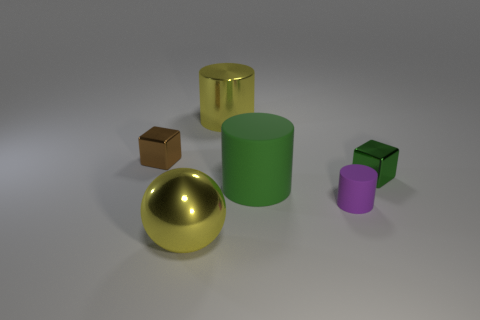Subtract all large cylinders. How many cylinders are left? 1 Add 2 tiny purple metallic blocks. How many objects exist? 8 Subtract all brown blocks. How many blocks are left? 1 Subtract all balls. How many objects are left? 5 Subtract 2 cubes. How many cubes are left? 0 Subtract all blue spheres. Subtract all green cubes. How many spheres are left? 1 Subtract all purple things. Subtract all brown objects. How many objects are left? 4 Add 1 metallic spheres. How many metallic spheres are left? 2 Add 5 green matte cylinders. How many green matte cylinders exist? 6 Subtract 0 purple spheres. How many objects are left? 6 